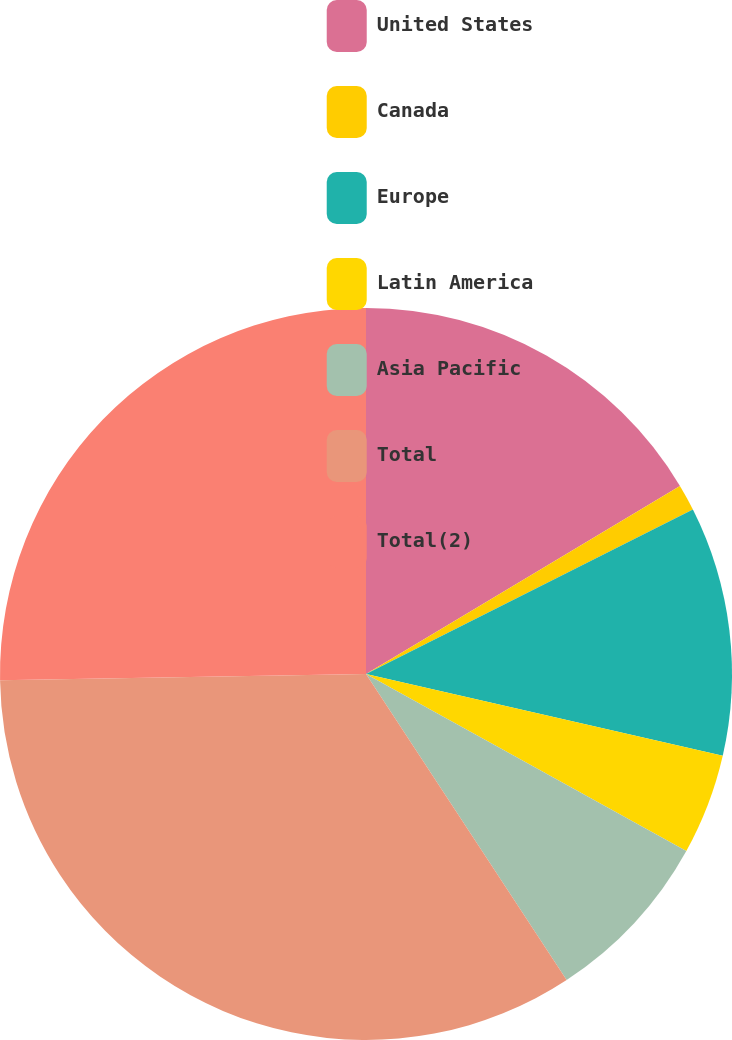<chart> <loc_0><loc_0><loc_500><loc_500><pie_chart><fcel>United States<fcel>Canada<fcel>Europe<fcel>Latin America<fcel>Asia Pacific<fcel>Total<fcel>Total(2)<nl><fcel>16.41%<fcel>1.17%<fcel>11.01%<fcel>4.45%<fcel>7.73%<fcel>33.97%<fcel>25.27%<nl></chart> 